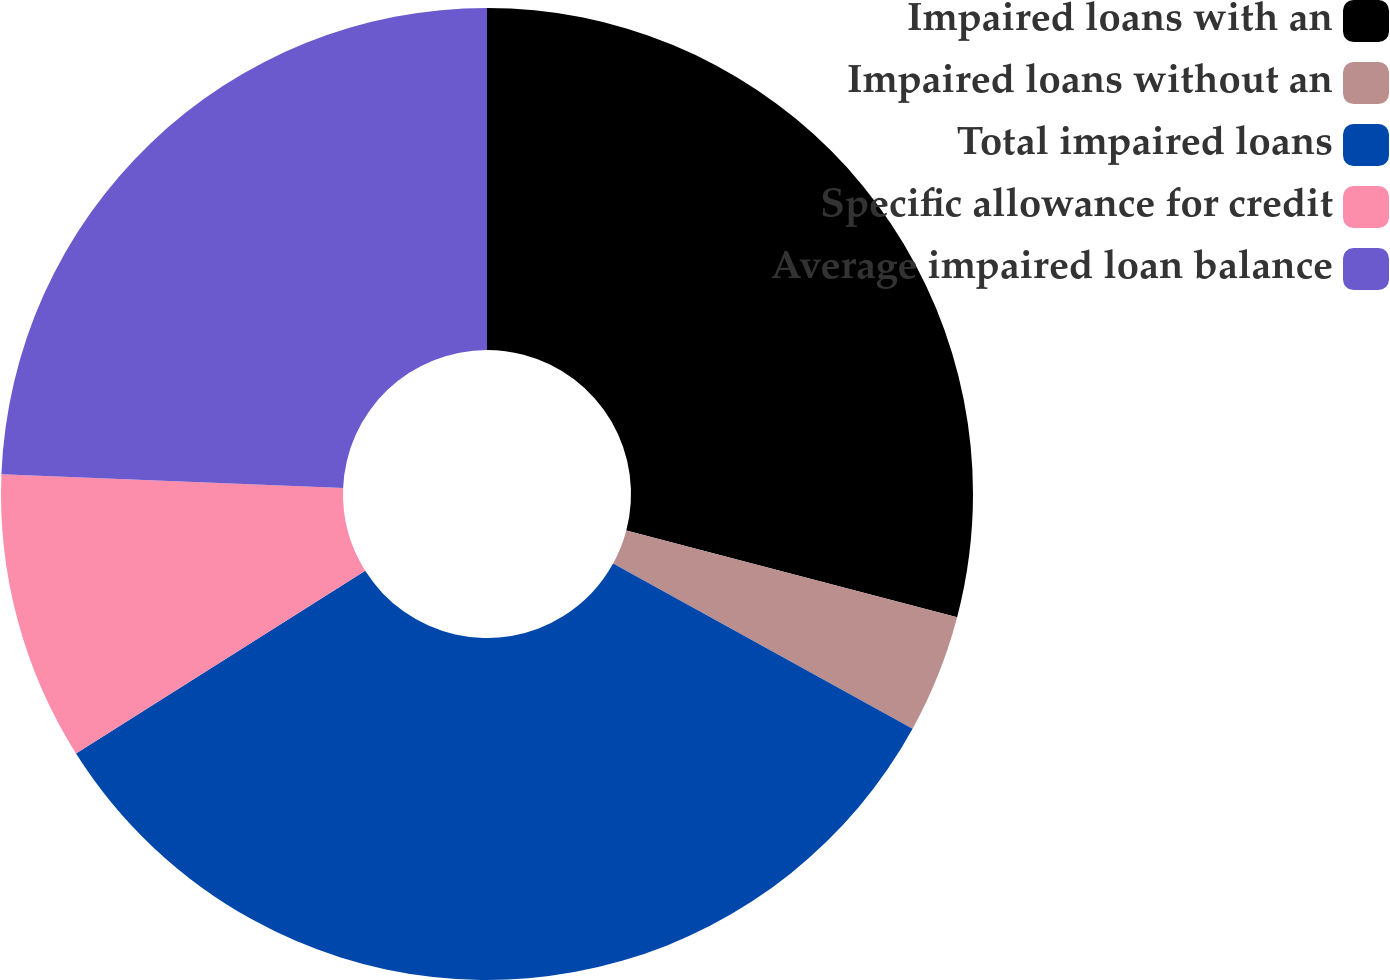Convert chart. <chart><loc_0><loc_0><loc_500><loc_500><pie_chart><fcel>Impaired loans with an<fcel>Impaired loans without an<fcel>Total impaired loans<fcel>Specific allowance for credit<fcel>Average impaired loan balance<nl><fcel>29.08%<fcel>3.94%<fcel>33.02%<fcel>9.61%<fcel>24.35%<nl></chart> 